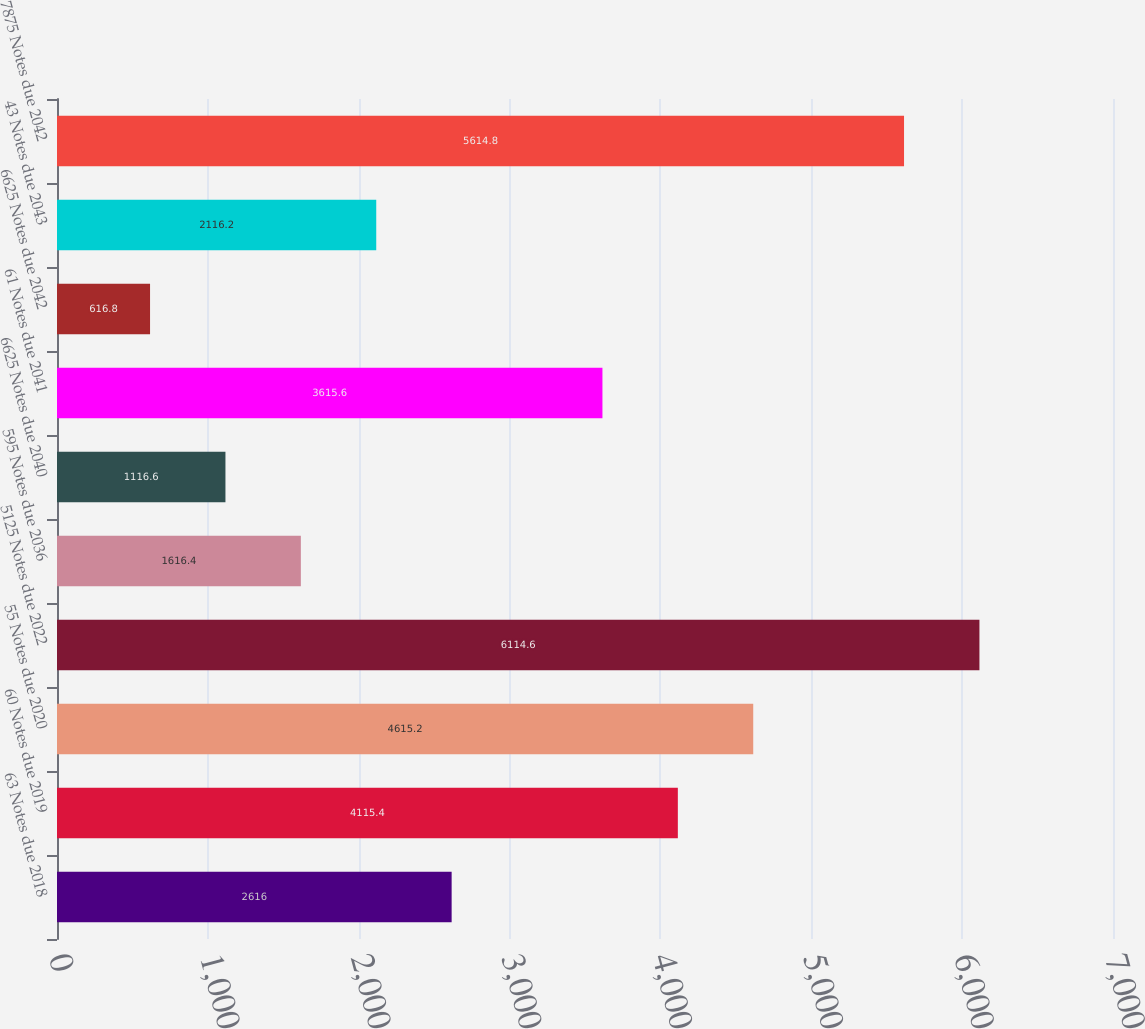<chart> <loc_0><loc_0><loc_500><loc_500><bar_chart><fcel>63 Notes due 2018<fcel>60 Notes due 2019<fcel>55 Notes due 2020<fcel>5125 Notes due 2022<fcel>595 Notes due 2036<fcel>6625 Notes due 2040<fcel>61 Notes due 2041<fcel>6625 Notes due 2042<fcel>43 Notes due 2043<fcel>7875 Notes due 2042<nl><fcel>2616<fcel>4115.4<fcel>4615.2<fcel>6114.6<fcel>1616.4<fcel>1116.6<fcel>3615.6<fcel>616.8<fcel>2116.2<fcel>5614.8<nl></chart> 